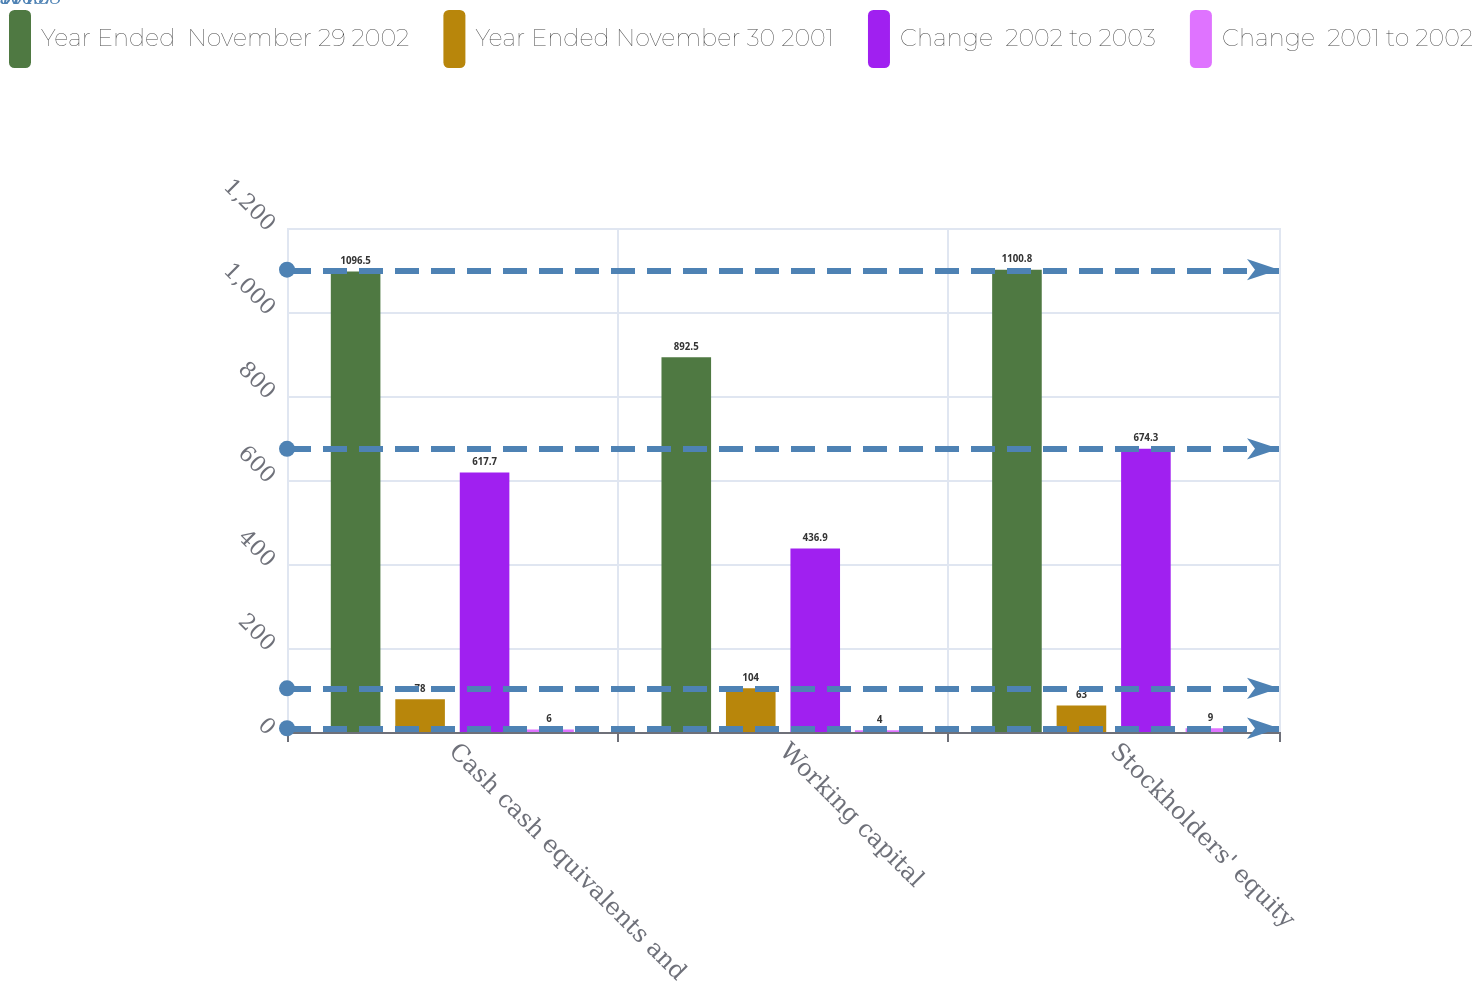Convert chart. <chart><loc_0><loc_0><loc_500><loc_500><stacked_bar_chart><ecel><fcel>Cash cash equivalents and<fcel>Working capital<fcel>Stockholders' equity<nl><fcel>Year Ended  November 29 2002<fcel>1096.5<fcel>892.5<fcel>1100.8<nl><fcel>Year Ended November 30 2001<fcel>78<fcel>104<fcel>63<nl><fcel>Change  2002 to 2003<fcel>617.7<fcel>436.9<fcel>674.3<nl><fcel>Change  2001 to 2002<fcel>6<fcel>4<fcel>9<nl></chart> 